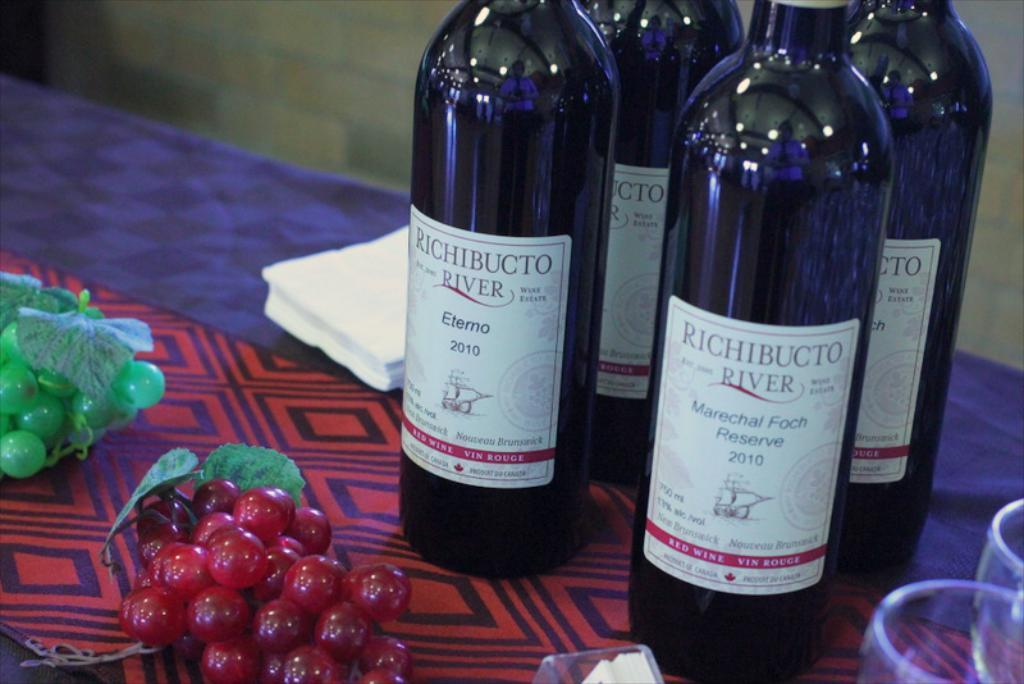<image>
Summarize the visual content of the image. Several bottles of Richibucto River wine are on a table. 